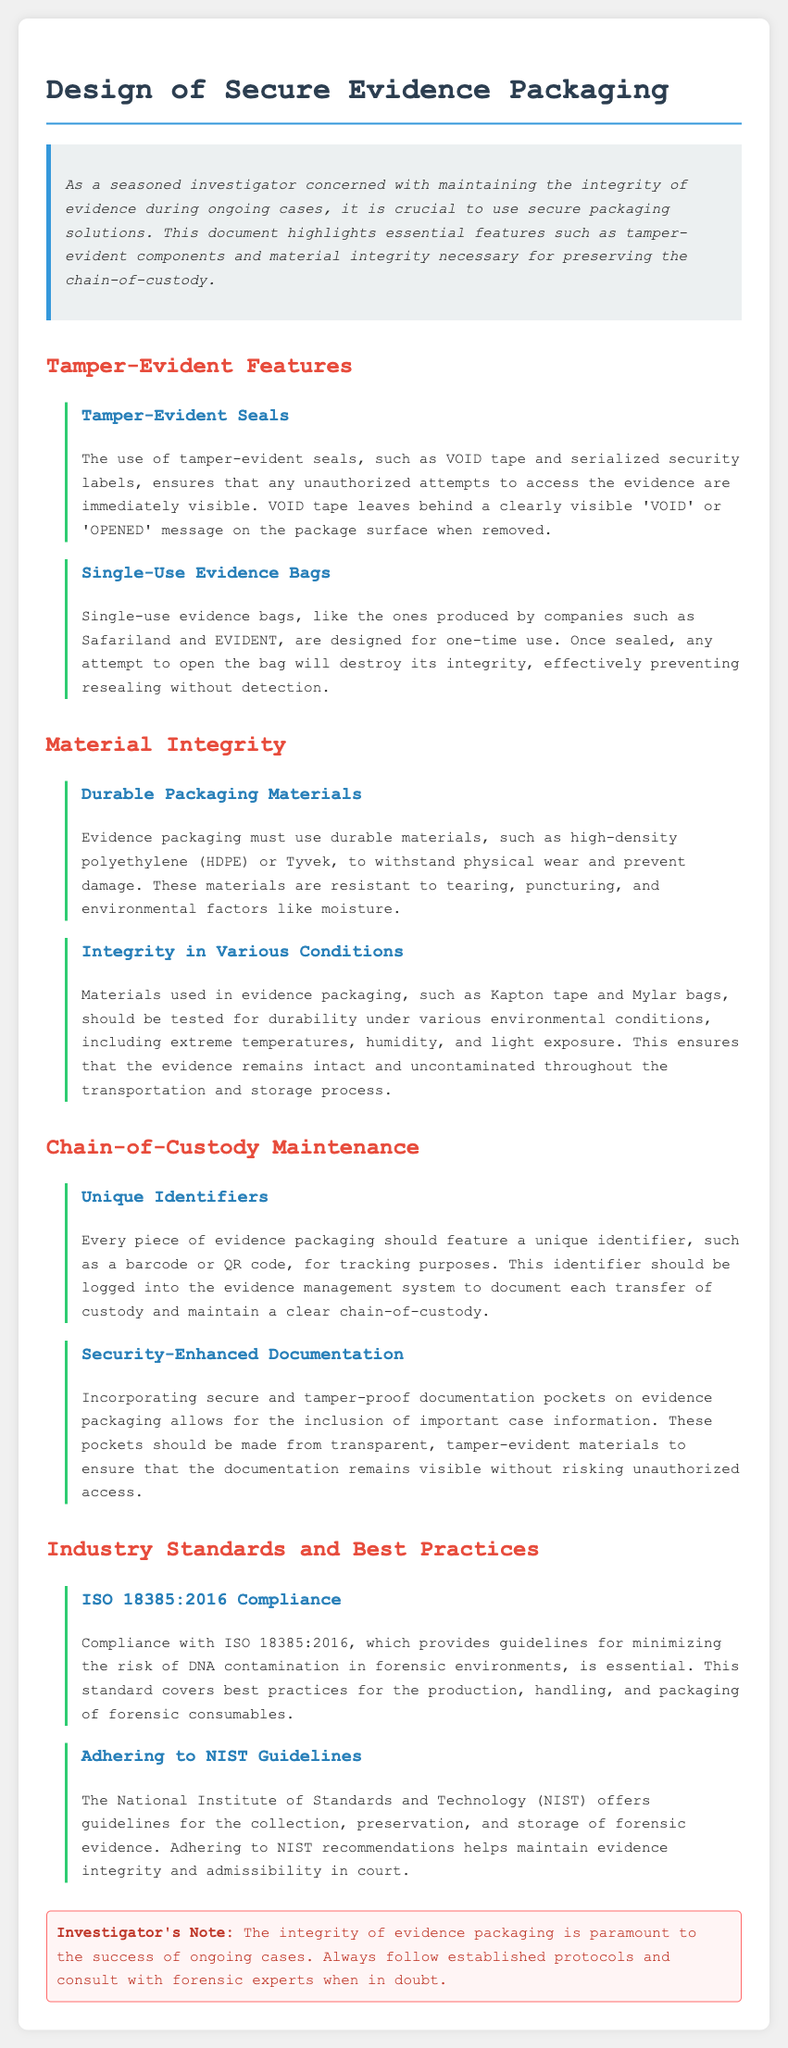What features are highlighted for tamper-evident packaging? The document outlines tamper-evident seals and single-use evidence bags as key features for secure evidence packaging.
Answer: tamper-evident seals and single-use evidence bags What materials are recommended for durable packaging? Durable packaging materials suggested include high-density polyethylene and Tyvek, which are resistant to wear and damage.
Answer: high-density polyethylene and Tyvek What is necessary for preserving chain-of-custody? Maintaining chain-of-custody requires unique identifiers like a barcode or QR code for tracking purposes.
Answer: unique identifiers Which industry standard is mentioned for forensic environments? The document refers to ISO 18385:2016, which provides guidelines to minimize the risk of DNA contamination.
Answer: ISO 18385:2016 What happens to single-use evidence bags if opened? The document states that opening single-use evidence bags destroys their integrity, preventing resealing without detection.
Answer: destroys integrity How do tamper-evident seals indicate unauthorized access? Tamper-evident seals leave behind a clearly visible 'VOID' or 'OPENED' message on the package surface when removed.
Answer: 'VOID' or 'OPENED' message Which organization provides guidelines for evidence preservation? The National Institute of Standards and Technology (NIST) is mentioned for offering guidelines on preservation and storage of forensic evidence.
Answer: National Institute of Standards and Technology What type of pockets are recommended for documentation on packaging? Secure and tamper-proof documentation pockets made from transparent, tamper-evident materials are recommended for evidence packaging.
Answer: secure and tamper-proof documentation pockets 